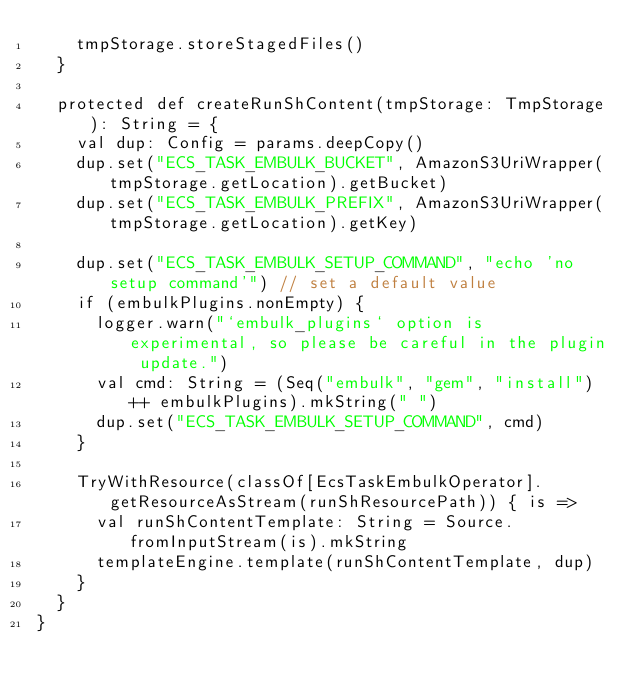Convert code to text. <code><loc_0><loc_0><loc_500><loc_500><_Scala_>    tmpStorage.storeStagedFiles()
  }

  protected def createRunShContent(tmpStorage: TmpStorage): String = {
    val dup: Config = params.deepCopy()
    dup.set("ECS_TASK_EMBULK_BUCKET", AmazonS3UriWrapper(tmpStorage.getLocation).getBucket)
    dup.set("ECS_TASK_EMBULK_PREFIX", AmazonS3UriWrapper(tmpStorage.getLocation).getKey)

    dup.set("ECS_TASK_EMBULK_SETUP_COMMAND", "echo 'no setup command'") // set a default value
    if (embulkPlugins.nonEmpty) {
      logger.warn("`embulk_plugins` option is experimental, so please be careful in the plugin update.")
      val cmd: String = (Seq("embulk", "gem", "install") ++ embulkPlugins).mkString(" ")
      dup.set("ECS_TASK_EMBULK_SETUP_COMMAND", cmd)
    }

    TryWithResource(classOf[EcsTaskEmbulkOperator].getResourceAsStream(runShResourcePath)) { is =>
      val runShContentTemplate: String = Source.fromInputStream(is).mkString
      templateEngine.template(runShContentTemplate, dup)
    }
  }
}
</code> 